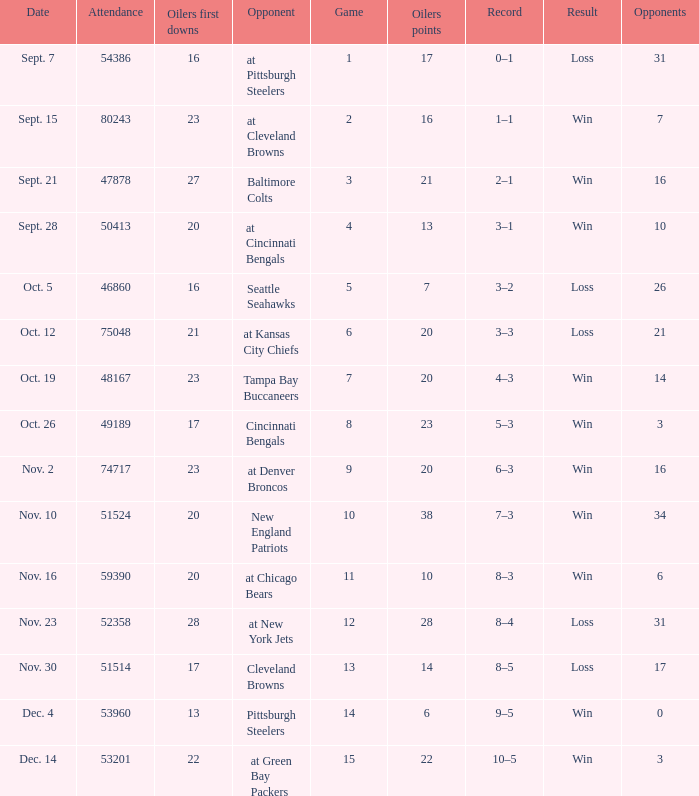What was the total opponents points for the game were the Oilers scored 21? 16.0. 